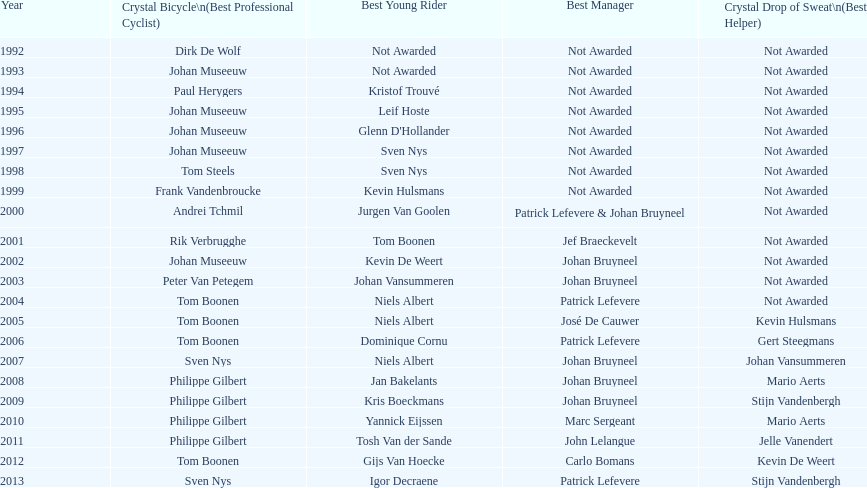Who won the most consecutive crystal bicycles? Philippe Gilbert. 